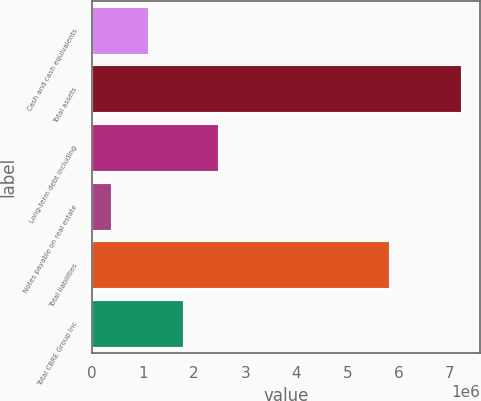Convert chart to OTSL. <chart><loc_0><loc_0><loc_500><loc_500><bar_chart><fcel>Cash and cash equivalents<fcel>Total assets<fcel>Long-term debt including<fcel>Notes payable on real estate<fcel>Total liabilities<fcel>Total CBRE Group Inc<nl><fcel>1.09318e+06<fcel>7.21914e+06<fcel>2.47269e+06<fcel>372912<fcel>5.80198e+06<fcel>1.77781e+06<nl></chart> 